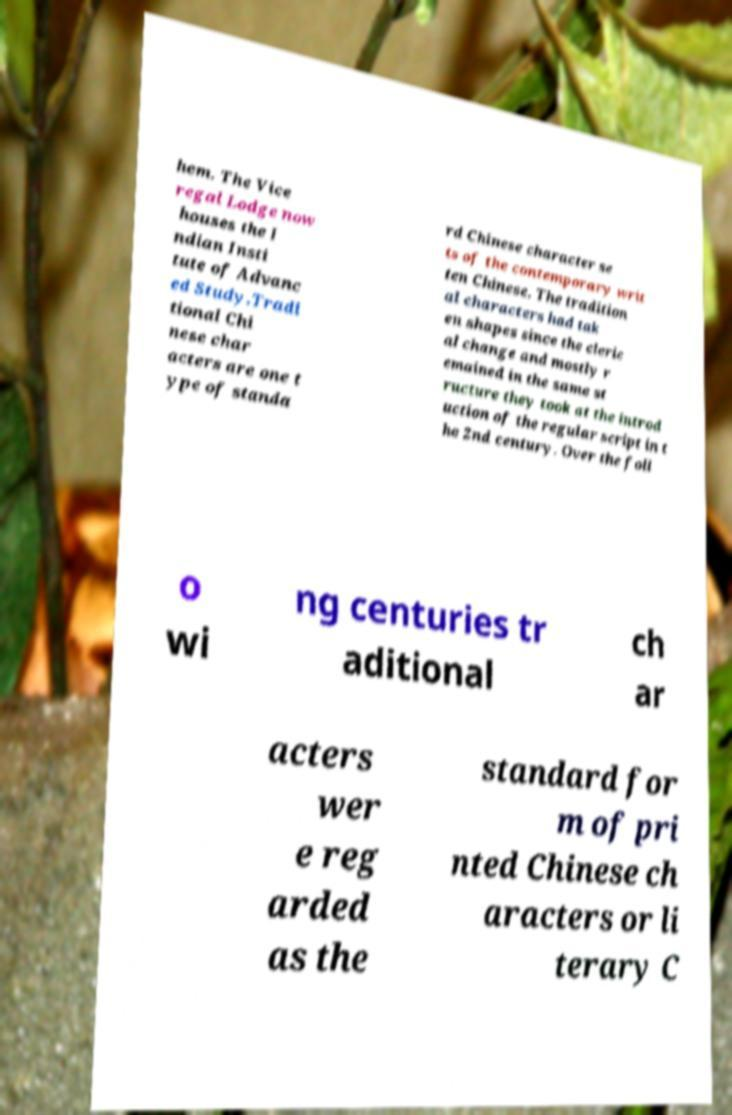Could you assist in decoding the text presented in this image and type it out clearly? hem. The Vice regal Lodge now houses the I ndian Insti tute of Advanc ed Study.Tradi tional Chi nese char acters are one t ype of standa rd Chinese character se ts of the contemporary writ ten Chinese. The tradition al characters had tak en shapes since the cleric al change and mostly r emained in the same st ructure they took at the introd uction of the regular script in t he 2nd century. Over the foll o wi ng centuries tr aditional ch ar acters wer e reg arded as the standard for m of pri nted Chinese ch aracters or li terary C 